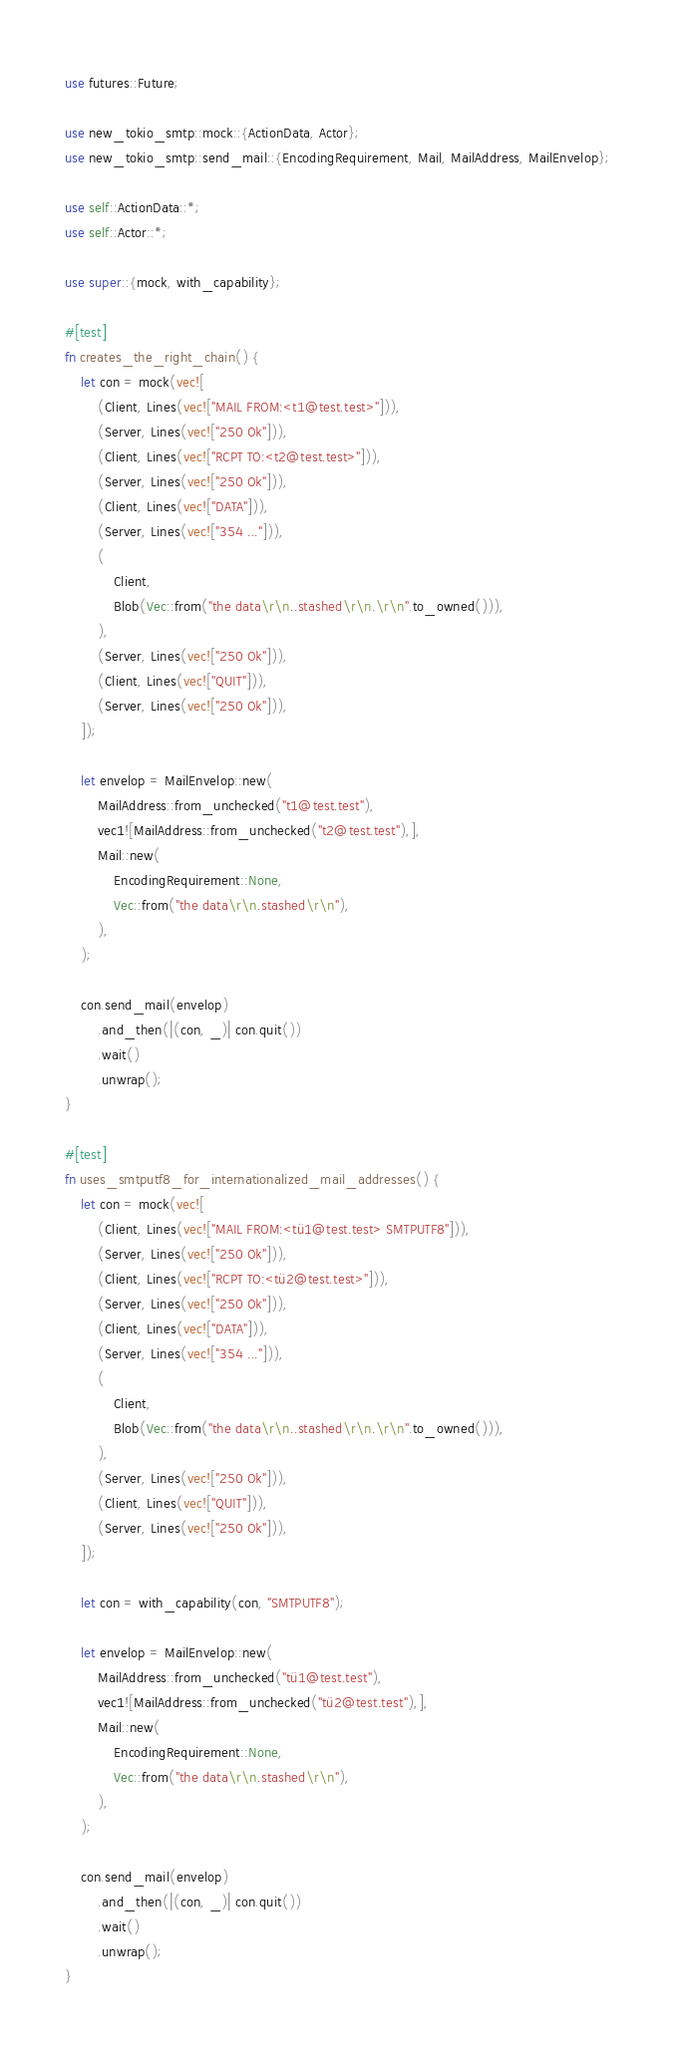Convert code to text. <code><loc_0><loc_0><loc_500><loc_500><_Rust_>use futures::Future;

use new_tokio_smtp::mock::{ActionData, Actor};
use new_tokio_smtp::send_mail::{EncodingRequirement, Mail, MailAddress, MailEnvelop};

use self::ActionData::*;
use self::Actor::*;

use super::{mock, with_capability};

#[test]
fn creates_the_right_chain() {
    let con = mock(vec![
        (Client, Lines(vec!["MAIL FROM:<t1@test.test>"])),
        (Server, Lines(vec!["250 Ok"])),
        (Client, Lines(vec!["RCPT TO:<t2@test.test>"])),
        (Server, Lines(vec!["250 Ok"])),
        (Client, Lines(vec!["DATA"])),
        (Server, Lines(vec!["354 ..."])),
        (
            Client,
            Blob(Vec::from("the data\r\n..stashed\r\n.\r\n".to_owned())),
        ),
        (Server, Lines(vec!["250 Ok"])),
        (Client, Lines(vec!["QUIT"])),
        (Server, Lines(vec!["250 Ok"])),
    ]);

    let envelop = MailEnvelop::new(
        MailAddress::from_unchecked("t1@test.test"),
        vec1![MailAddress::from_unchecked("t2@test.test"),],
        Mail::new(
            EncodingRequirement::None,
            Vec::from("the data\r\n.stashed\r\n"),
        ),
    );

    con.send_mail(envelop)
        .and_then(|(con, _)| con.quit())
        .wait()
        .unwrap();
}

#[test]
fn uses_smtputf8_for_internationalized_mail_addresses() {
    let con = mock(vec![
        (Client, Lines(vec!["MAIL FROM:<tü1@test.test> SMTPUTF8"])),
        (Server, Lines(vec!["250 Ok"])),
        (Client, Lines(vec!["RCPT TO:<tü2@test.test>"])),
        (Server, Lines(vec!["250 Ok"])),
        (Client, Lines(vec!["DATA"])),
        (Server, Lines(vec!["354 ..."])),
        (
            Client,
            Blob(Vec::from("the data\r\n..stashed\r\n.\r\n".to_owned())),
        ),
        (Server, Lines(vec!["250 Ok"])),
        (Client, Lines(vec!["QUIT"])),
        (Server, Lines(vec!["250 Ok"])),
    ]);

    let con = with_capability(con, "SMTPUTF8");

    let envelop = MailEnvelop::new(
        MailAddress::from_unchecked("tü1@test.test"),
        vec1![MailAddress::from_unchecked("tü2@test.test"),],
        Mail::new(
            EncodingRequirement::None,
            Vec::from("the data\r\n.stashed\r\n"),
        ),
    );

    con.send_mail(envelop)
        .and_then(|(con, _)| con.quit())
        .wait()
        .unwrap();
}
</code> 